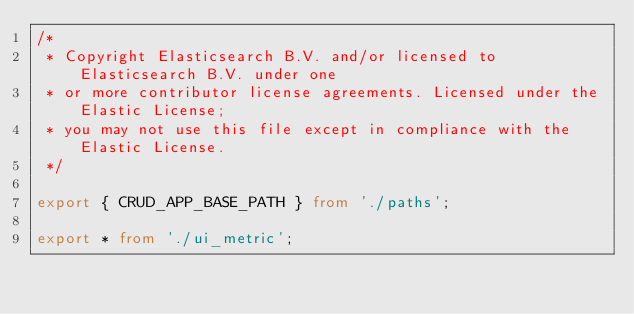Convert code to text. <code><loc_0><loc_0><loc_500><loc_500><_TypeScript_>/*
 * Copyright Elasticsearch B.V. and/or licensed to Elasticsearch B.V. under one
 * or more contributor license agreements. Licensed under the Elastic License;
 * you may not use this file except in compliance with the Elastic License.
 */

export { CRUD_APP_BASE_PATH } from './paths';

export * from './ui_metric';
</code> 